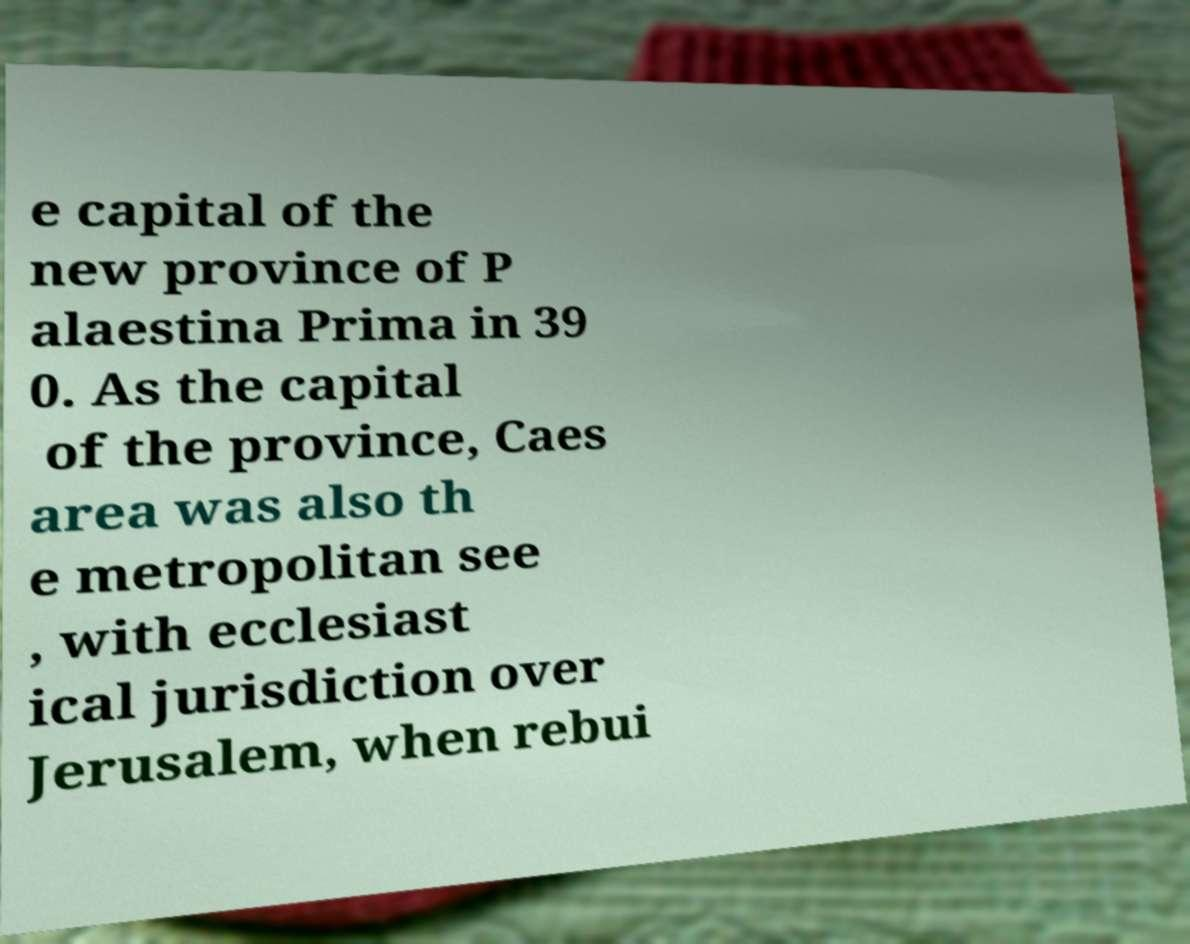Please read and relay the text visible in this image. What does it say? e capital of the new province of P alaestina Prima in 39 0. As the capital of the province, Caes area was also th e metropolitan see , with ecclesiast ical jurisdiction over Jerusalem, when rebui 